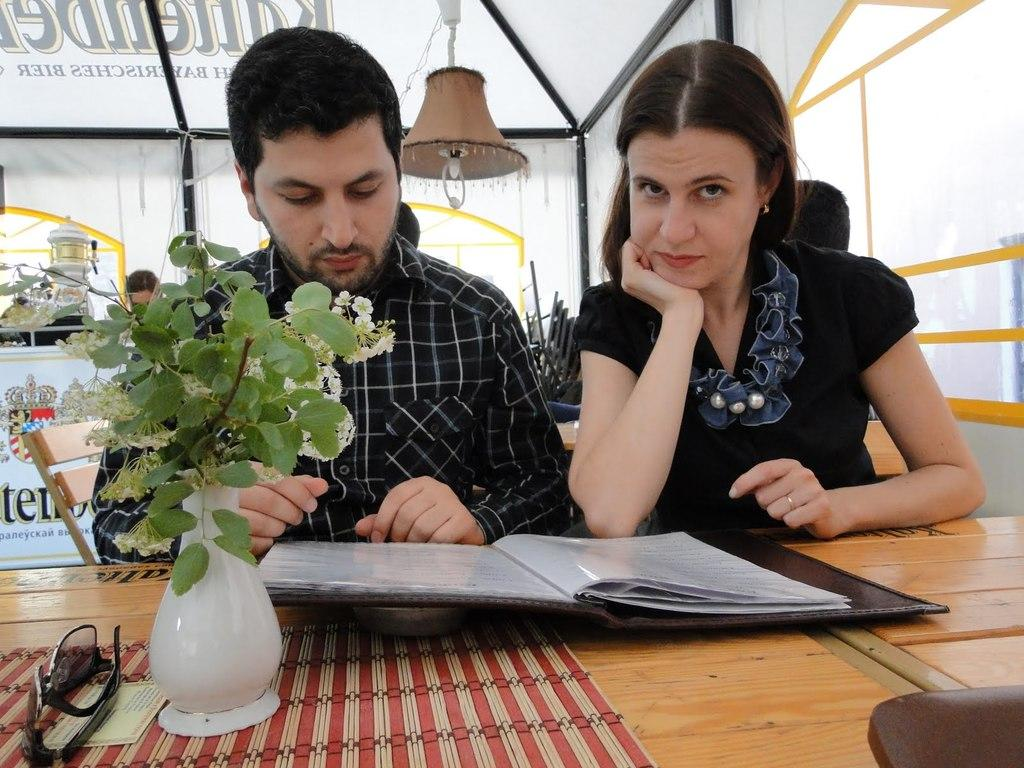What piece of furniture is present in the image? There is a table in the image. Who is present in the image? There are two people sitting on chairs in the image. What objects are on the table? There is a flask, goggles, and a book on the table. What type of organization is the people working for in the image? There is no indication in the image that the people are working for any organization. 